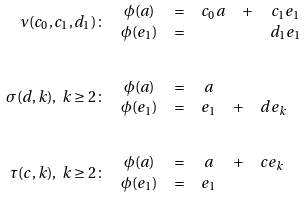<formula> <loc_0><loc_0><loc_500><loc_500>\nu ( c _ { 0 } , c _ { 1 } , d _ { 1 } ) \colon & \quad \begin{matrix} \phi ( a ) & = & c _ { 0 } a & + & c _ { 1 } e _ { 1 } \\ \phi ( e _ { 1 } ) & = & & & d _ { 1 } e _ { 1 } \end{matrix} \\ \\ \sigma ( d , k ) , \ k \geq 2 \colon & \quad \begin{matrix} \phi ( a ) & = & a & & \\ \phi ( e _ { 1 } ) & = & e _ { 1 } & + & d e _ { k } \end{matrix} \\ \\ \tau ( c , k ) , \ k \geq 2 \colon & \quad \begin{matrix} \phi ( a ) & = & a & + & c e _ { k } \\ \phi ( e _ { 1 } ) & = & e _ { 1 } & & \end{matrix}</formula> 